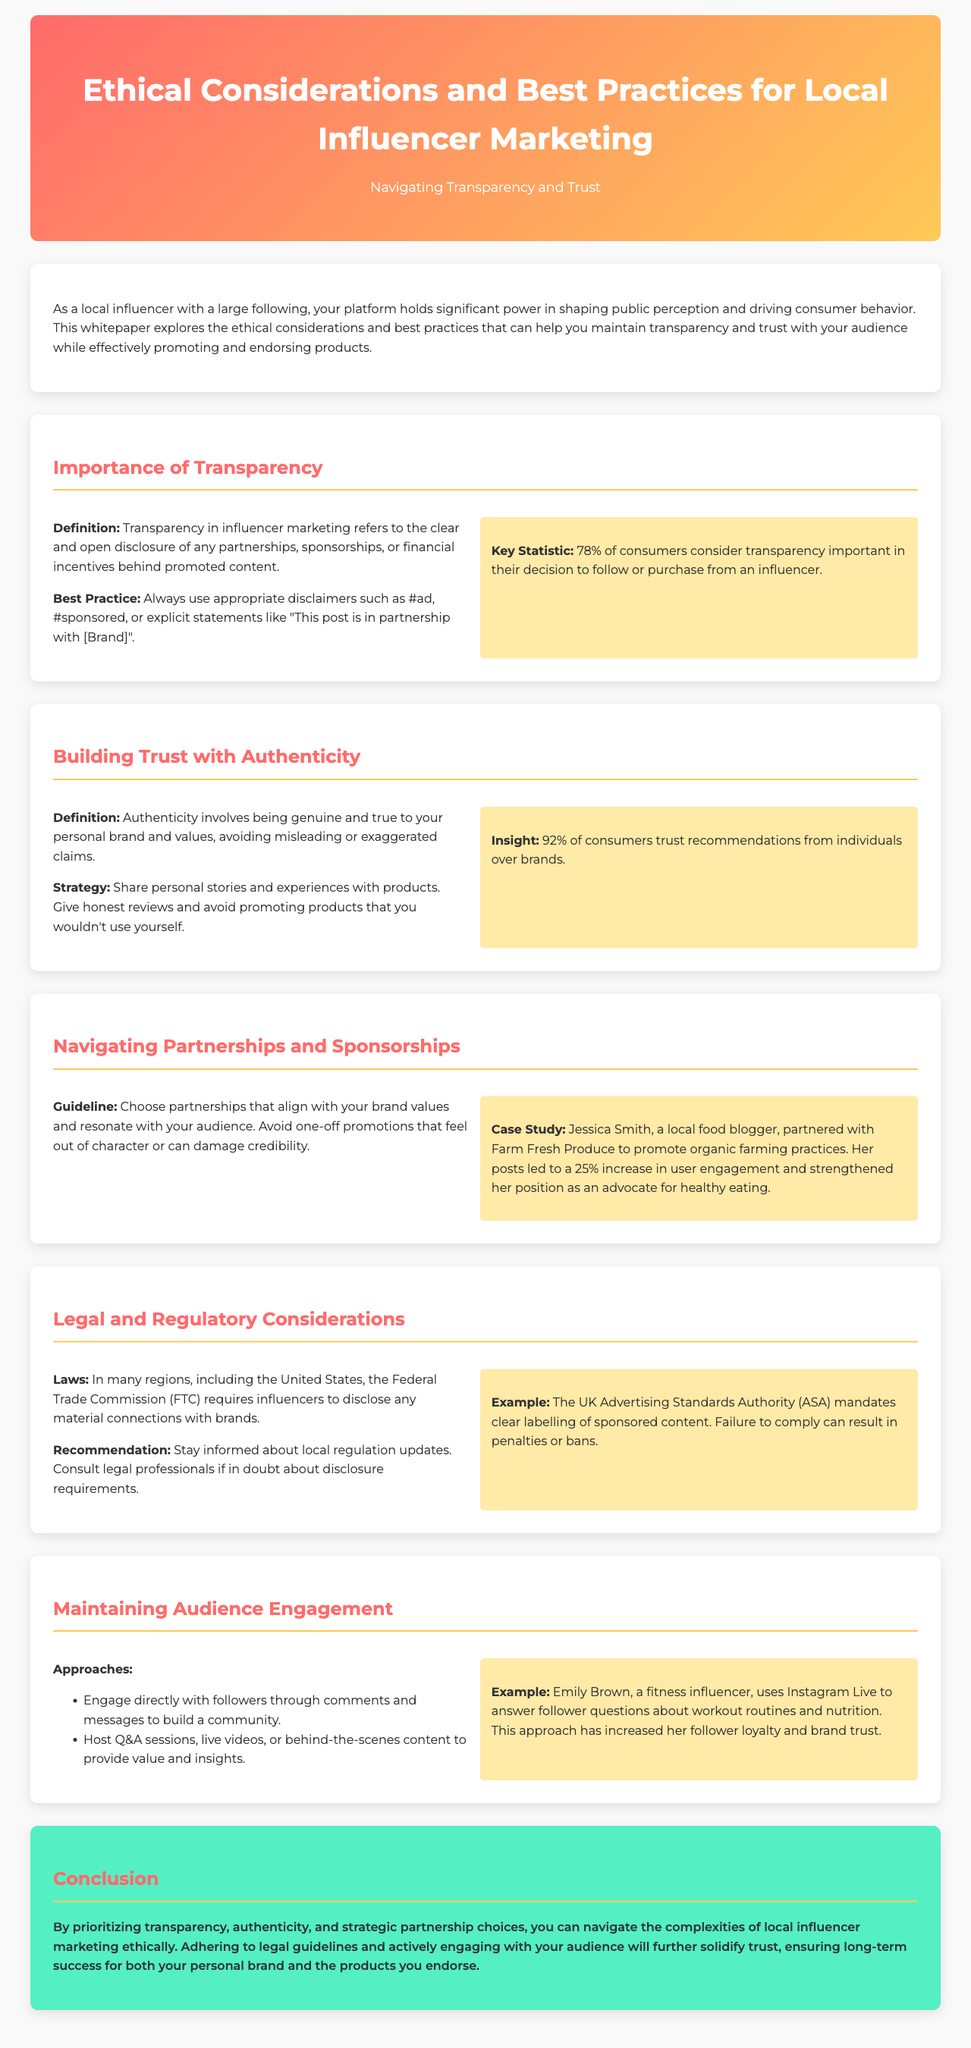What is the main focus of the whitepaper? The main focus of the whitepaper is to explore ethical considerations and best practices for local influencer marketing, specifically in terms of transparency and trust.
Answer: Ethical considerations and best practices for local influencer marketing What percentage of consumers consider transparency important? The document states that 78% of consumers consider transparency important in their decision-making process regarding influencers.
Answer: 78% What hashtag should influencers use to disclose sponsored content? The document advises influencers to use appropriate disclaimers such as #ad or #sponsored.
Answer: #ad Which influencer is mentioned in a case study related to organic farming? The document mentions Jessica Smith as the influencer in the case study regarding her partnership with Farm Fresh Produce.
Answer: Jessica Smith What legal agency requires influencers to disclose material connections with brands? The document refers to the Federal Trade Commission (FTC) as the agency that requires disclosure.
Answer: Federal Trade Commission (FTC) What approach did Emily Brown, the fitness influencer, take to increase follower loyalty? Emily Brown engaged directly with her followers through Instagram Live to answer questions, increasing follower loyalty and brand trust.
Answer: Instagram Live What does authenticity in influencer marketing involve? Authenticity involves being genuine and true to your personal brand and values, avoiding misleading or exaggerated claims.
Answer: Being genuine and true to your personal brand What type of content should influencers share to maintain audience engagement, according to the document? The document suggests hosting Q&A sessions or behind-the-scenes content as effective means to maintain engagement.
Answer: Q&A sessions What is recommended to stay informed about local regulation updates in influencer marketing? The whitepaper recommends consulting legal professionals if in doubt about disclosure requirements for transparency.
Answer: Consult legal professionals 